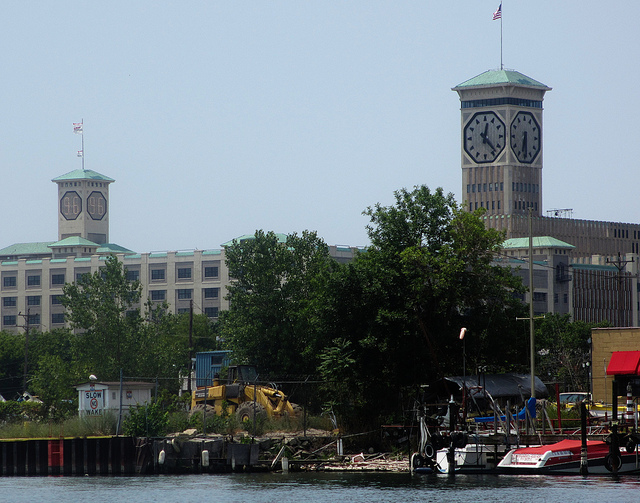<image>What country is this? It is ambiguous to determine the country. It could be England, USA, Spain or France. What country is this? I am not sure what country this is. It could be England, USA, America, Spain, or France. 